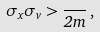Convert formula to latex. <formula><loc_0><loc_0><loc_500><loc_500>\sigma _ { x } \sigma _ { v } > \frac { } { 2 m } \, ,</formula> 